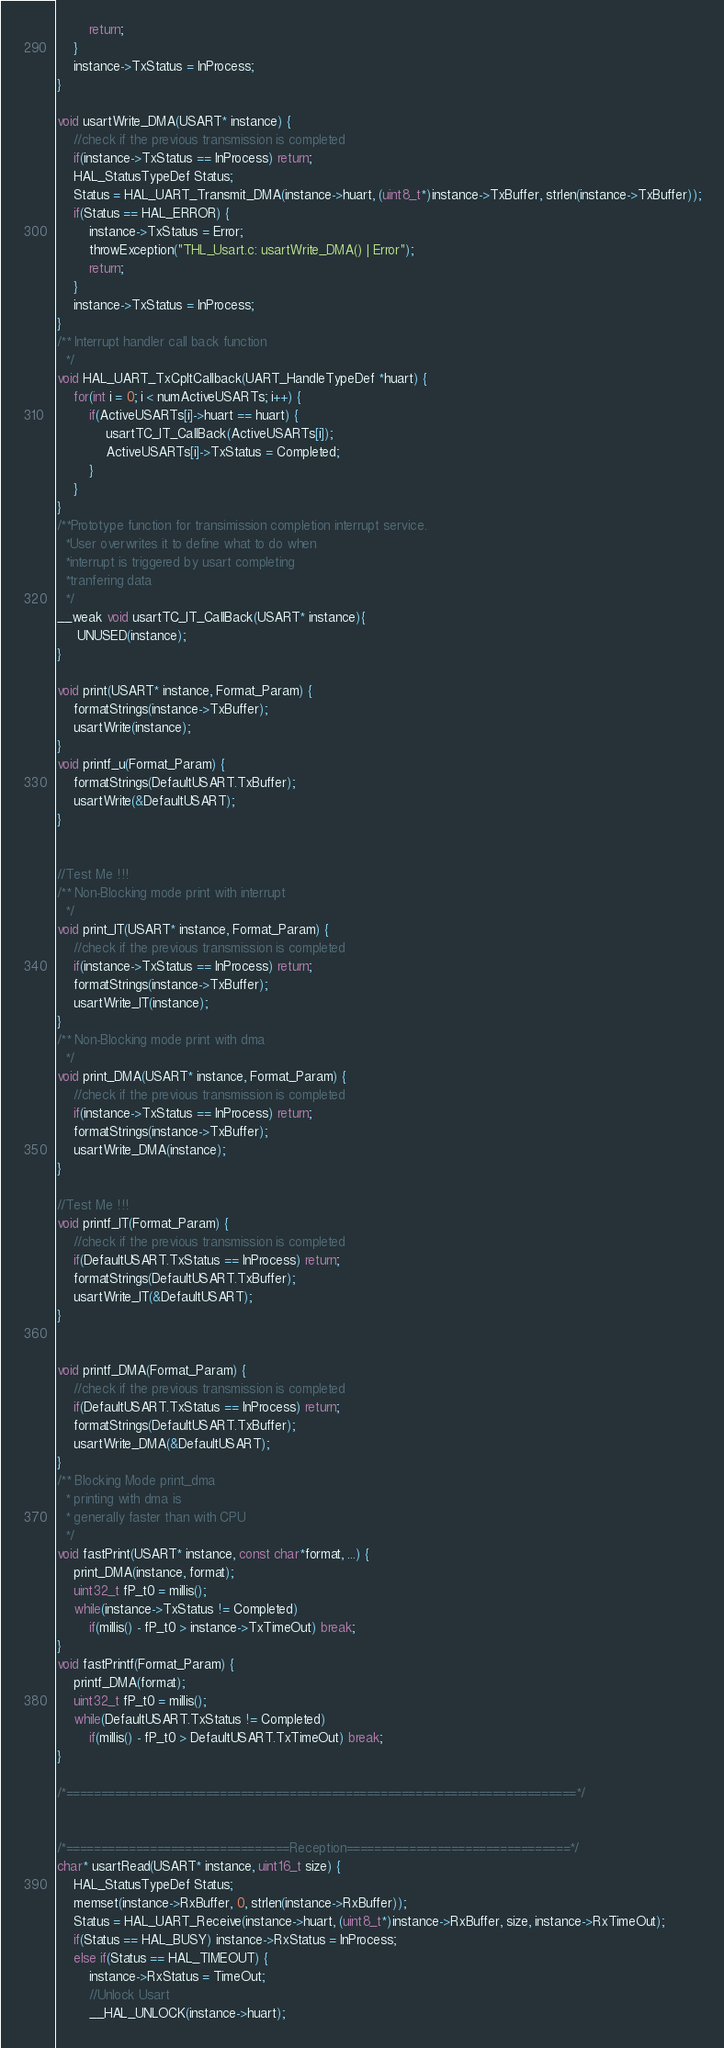Convert code to text. <code><loc_0><loc_0><loc_500><loc_500><_C_>		return;
	}
	instance->TxStatus = InProcess;
}

void usartWrite_DMA(USART* instance) {
	//check if the previous transmission is completed
	if(instance->TxStatus == InProcess) return;
	HAL_StatusTypeDef Status;
	Status = HAL_UART_Transmit_DMA(instance->huart, (uint8_t*)instance->TxBuffer, strlen(instance->TxBuffer));
	if(Status == HAL_ERROR) {
		instance->TxStatus = Error;
		throwException("THL_Usart.c: usartWrite_DMA() | Error");
		return;
	}
	instance->TxStatus = InProcess;
} 
/** Interrupt handler call back function
  */
void HAL_UART_TxCpltCallback(UART_HandleTypeDef *huart) {
	for(int i = 0; i < numActiveUSARTs; i++) {
		if(ActiveUSARTs[i]->huart == huart) {
			usartTC_IT_CallBack(ActiveUSARTs[i]);
			ActiveUSARTs[i]->TxStatus = Completed;
		}
	}
}
/**Prototype function for transimission completion interrupt service. 
  *User overwrites it to define what to do when 
  *interrupt is triggered by usart completing 
  *tranfering data
  */
__weak void usartTC_IT_CallBack(USART* instance){
	 UNUSED(instance);
}

void print(USART* instance, Format_Param) {
	formatStrings(instance->TxBuffer);
	usartWrite(instance);
}
void printf_u(Format_Param) {
	formatStrings(DefaultUSART.TxBuffer);
	usartWrite(&DefaultUSART);
}


//Test Me !!!
/** Non-Blocking mode print with interrupt
  */
void print_IT(USART* instance, Format_Param) {
	//check if the previous transmission is completed
	if(instance->TxStatus == InProcess) return;
	formatStrings(instance->TxBuffer);
	usartWrite_IT(instance);
}
/** Non-Blocking mode print with dma
  */
void print_DMA(USART* instance, Format_Param) {
	//check if the previous transmission is completed
	if(instance->TxStatus == InProcess) return;
	formatStrings(instance->TxBuffer);
	usartWrite_DMA(instance);
}

//Test Me !!!
void printf_IT(Format_Param) {
	//check if the previous transmission is completed
	if(DefaultUSART.TxStatus == InProcess) return;
	formatStrings(DefaultUSART.TxBuffer);
	usartWrite_IT(&DefaultUSART);
}


void printf_DMA(Format_Param) {
	//check if the previous transmission is completed
	if(DefaultUSART.TxStatus == InProcess) return;
	formatStrings(DefaultUSART.TxBuffer);
	usartWrite_DMA(&DefaultUSART);
}
/** Blocking Mode print_dma 
  * printing with dma is 
  * generally faster than with CPU
  */
void fastPrint(USART* instance, const char*format, ...) {
	print_DMA(instance, format);
	uint32_t fP_t0 = millis();
	while(instance->TxStatus != Completed)
		if(millis() - fP_t0 > instance->TxTimeOut) break;
}
void fastPrintf(Format_Param) {
	printf_DMA(format);
	uint32_t fP_t0 = millis();
	while(DefaultUSART.TxStatus != Completed)
		if(millis() - fP_t0 > DefaultUSART.TxTimeOut) break;
}

/*=========================================================================*/


/*================================Reception================================*/
char* usartRead(USART* instance, uint16_t size) {
	HAL_StatusTypeDef Status;
	memset(instance->RxBuffer, 0, strlen(instance->RxBuffer));
	Status = HAL_UART_Receive(instance->huart, (uint8_t*)instance->RxBuffer, size, instance->RxTimeOut);
	if(Status == HAL_BUSY) instance->RxStatus = InProcess;
	else if(Status == HAL_TIMEOUT) {
		instance->RxStatus = TimeOut;
		//Unlock Usart
		__HAL_UNLOCK(instance->huart);</code> 